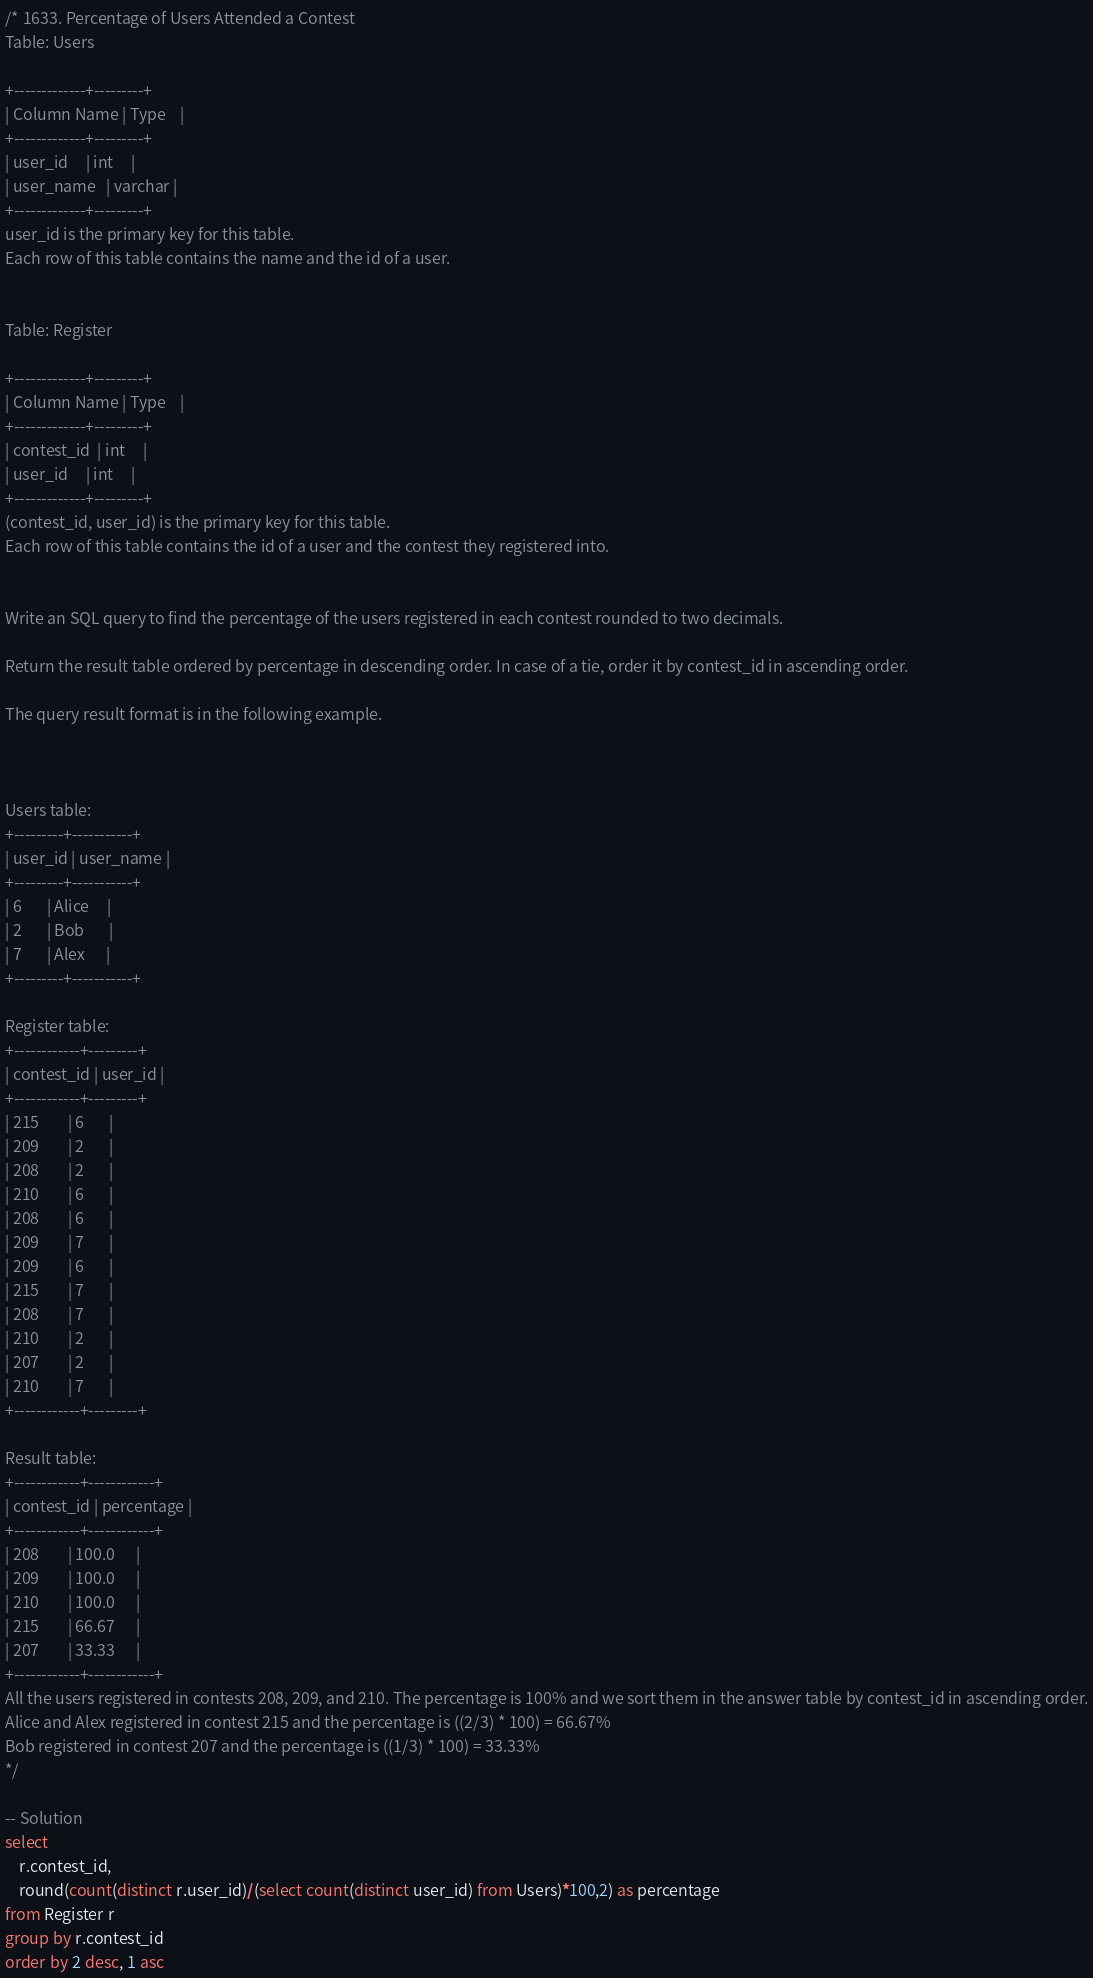<code> <loc_0><loc_0><loc_500><loc_500><_SQL_>/* 1633. Percentage of Users Attended a Contest
Table: Users

+-------------+---------+
| Column Name | Type    |
+-------------+---------+
| user_id     | int     |
| user_name   | varchar |
+-------------+---------+
user_id is the primary key for this table.
Each row of this table contains the name and the id of a user.
 

Table: Register

+-------------+---------+
| Column Name | Type    |
+-------------+---------+
| contest_id  | int     |
| user_id     | int     |
+-------------+---------+
(contest_id, user_id) is the primary key for this table.
Each row of this table contains the id of a user and the contest they registered into.
 

Write an SQL query to find the percentage of the users registered in each contest rounded to two decimals.

Return the result table ordered by percentage in descending order. In case of a tie, order it by contest_id in ascending order.

The query result format is in the following example.

 

Users table:
+---------+-----------+
| user_id | user_name |
+---------+-----------+
| 6       | Alice     |
| 2       | Bob       |
| 7       | Alex      |
+---------+-----------+

Register table:
+------------+---------+
| contest_id | user_id |
+------------+---------+
| 215        | 6       |
| 209        | 2       |
| 208        | 2       |
| 210        | 6       |
| 208        | 6       |
| 209        | 7       |
| 209        | 6       |
| 215        | 7       |
| 208        | 7       |
| 210        | 2       |
| 207        | 2       |
| 210        | 7       |
+------------+---------+

Result table:
+------------+------------+
| contest_id | percentage |
+------------+------------+
| 208        | 100.0      |
| 209        | 100.0      |
| 210        | 100.0      |
| 215        | 66.67      |
| 207        | 33.33      |
+------------+------------+
All the users registered in contests 208, 209, and 210. The percentage is 100% and we sort them in the answer table by contest_id in ascending order.
Alice and Alex registered in contest 215 and the percentage is ((2/3) * 100) = 66.67%
Bob registered in contest 207 and the percentage is ((1/3) * 100) = 33.33%
*/

-- Solution 
select 
    r.contest_id, 
    round(count(distinct r.user_id)/(select count(distinct user_id) from Users)*100,2) as percentage
from Register r
group by r.contest_id
order by 2 desc, 1 asc
</code> 